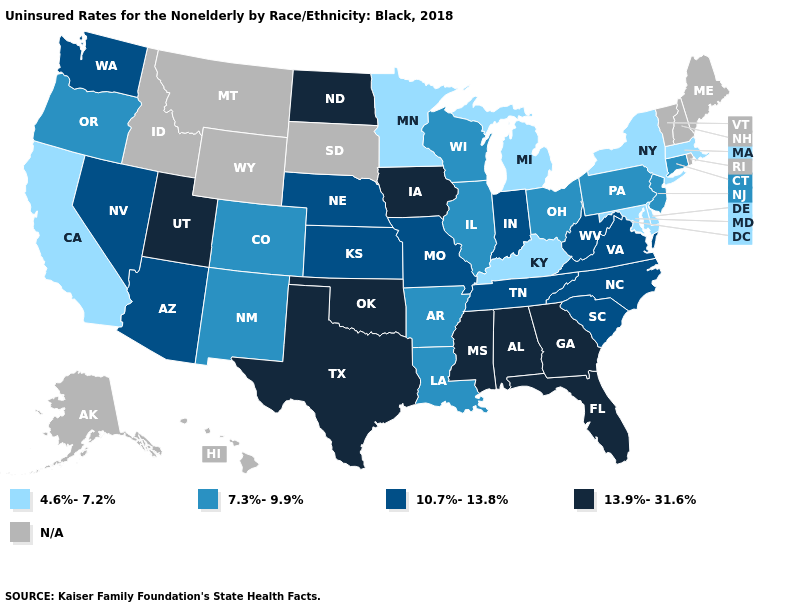Which states have the lowest value in the MidWest?
Write a very short answer. Michigan, Minnesota. What is the highest value in states that border Michigan?
Short answer required. 10.7%-13.8%. Name the states that have a value in the range 10.7%-13.8%?
Keep it brief. Arizona, Indiana, Kansas, Missouri, Nebraska, Nevada, North Carolina, South Carolina, Tennessee, Virginia, Washington, West Virginia. Among the states that border Utah , which have the lowest value?
Keep it brief. Colorado, New Mexico. What is the value of Kansas?
Answer briefly. 10.7%-13.8%. Among the states that border Florida , which have the lowest value?
Give a very brief answer. Alabama, Georgia. Name the states that have a value in the range 7.3%-9.9%?
Give a very brief answer. Arkansas, Colorado, Connecticut, Illinois, Louisiana, New Jersey, New Mexico, Ohio, Oregon, Pennsylvania, Wisconsin. Does Texas have the highest value in the USA?
Concise answer only. Yes. Which states hav the highest value in the Northeast?
Answer briefly. Connecticut, New Jersey, Pennsylvania. Does Michigan have the highest value in the MidWest?
Quick response, please. No. Name the states that have a value in the range 4.6%-7.2%?
Concise answer only. California, Delaware, Kentucky, Maryland, Massachusetts, Michigan, Minnesota, New York. What is the value of Pennsylvania?
Quick response, please. 7.3%-9.9%. Does Colorado have the lowest value in the USA?
Answer briefly. No. What is the value of Arizona?
Give a very brief answer. 10.7%-13.8%. 